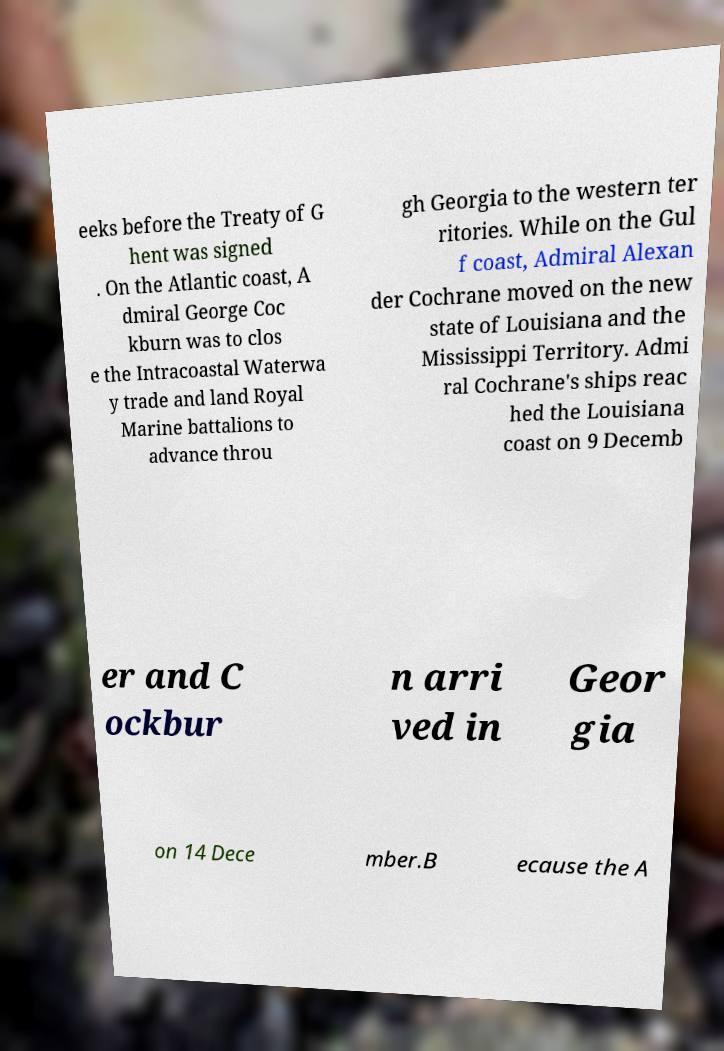For documentation purposes, I need the text within this image transcribed. Could you provide that? eeks before the Treaty of G hent was signed . On the Atlantic coast, A dmiral George Coc kburn was to clos e the Intracoastal Waterwa y trade and land Royal Marine battalions to advance throu gh Georgia to the western ter ritories. While on the Gul f coast, Admiral Alexan der Cochrane moved on the new state of Louisiana and the Mississippi Territory. Admi ral Cochrane's ships reac hed the Louisiana coast on 9 Decemb er and C ockbur n arri ved in Geor gia on 14 Dece mber.B ecause the A 